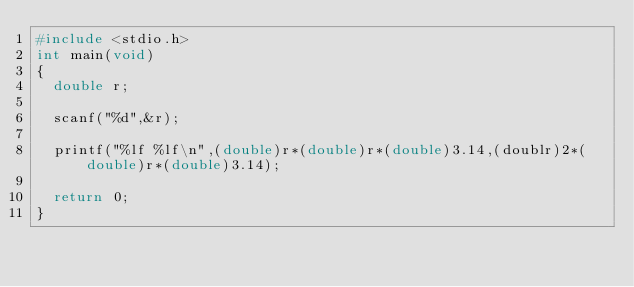Convert code to text. <code><loc_0><loc_0><loc_500><loc_500><_C_>#include <stdio.h>
int main(void)
{
  double r;

  scanf("%d",&r);

  printf("%lf %lf\n",(double)r*(double)r*(double)3.14,(doublr)2*(double)r*(double)3.14);

  return 0;
}</code> 